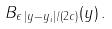<formula> <loc_0><loc_0><loc_500><loc_500>B _ { \epsilon \, | y - y _ { i } | / ( 2 c ) } ( y ) \, .</formula> 